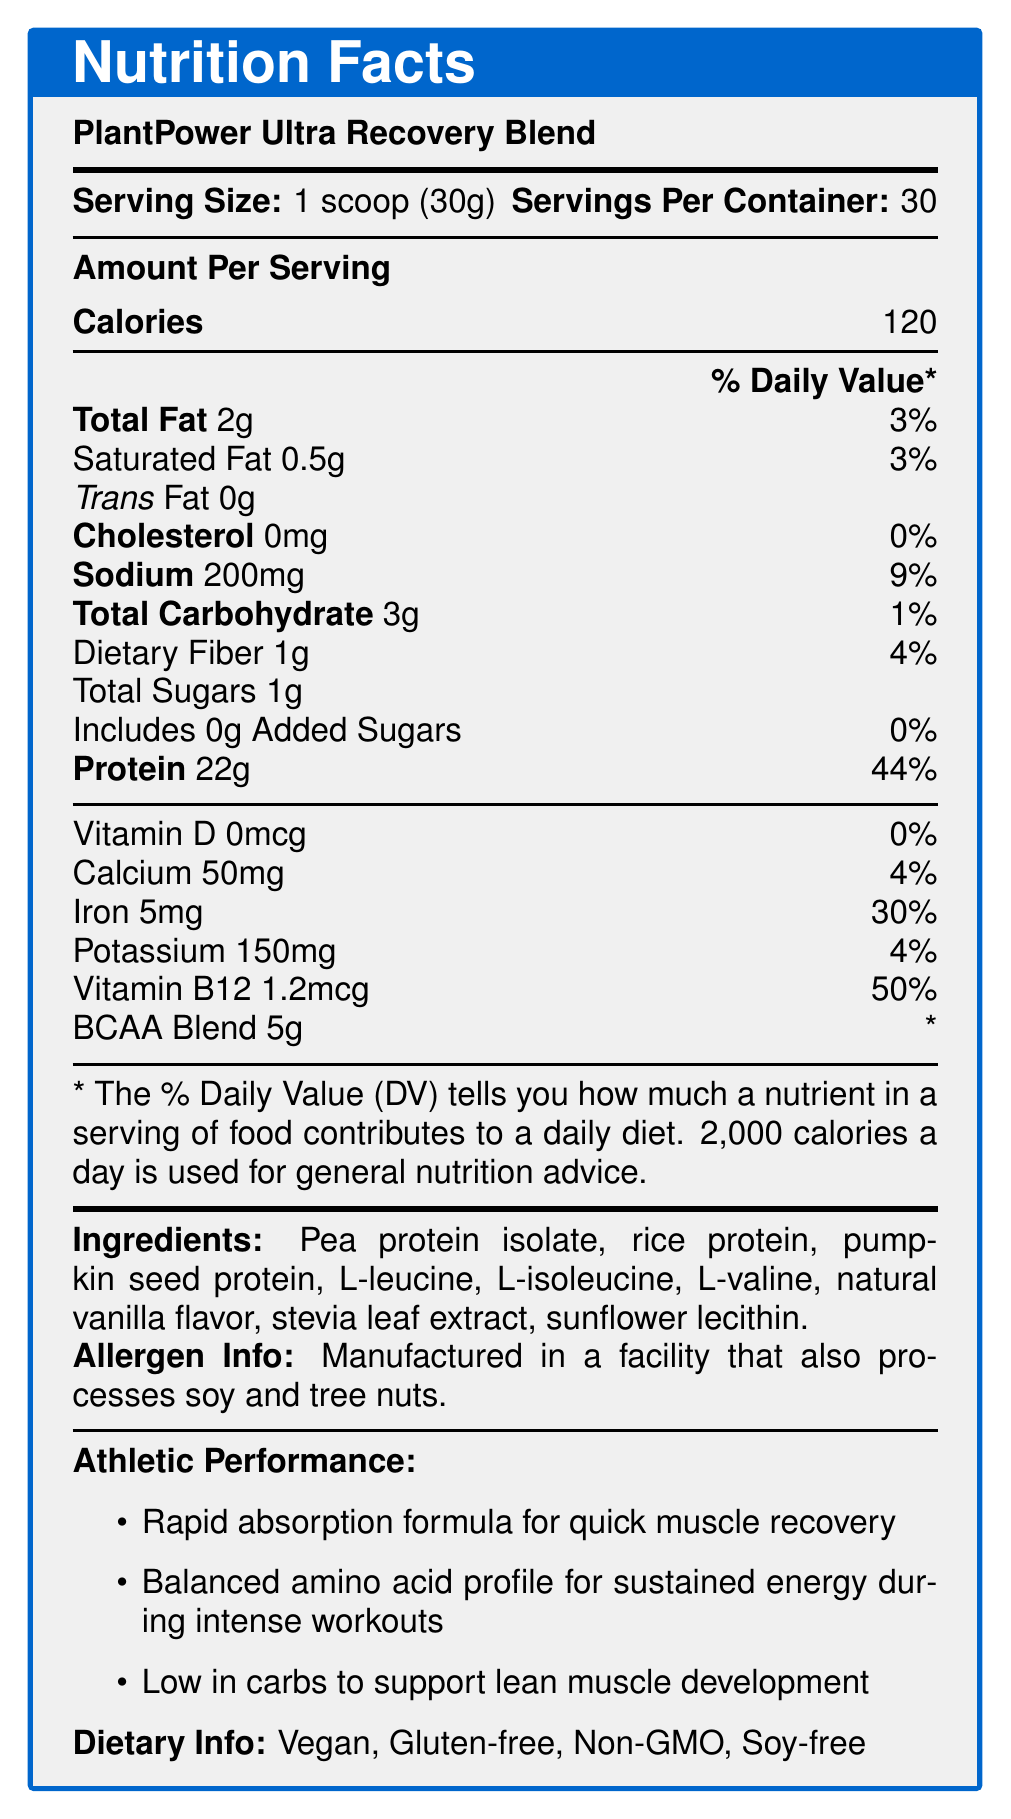Which product is described in the document? The product name is mentioned at the very start of the document.
Answer: PlantPower Ultra Recovery Blend What is the serving size for this protein powder? The serving size is clearly listed next to the product name and serving information.
Answer: 1 scoop (30g) How many calories does one serving contain? The document states that each serving contains 120 calories.
Answer: 120 What is the total fat content per serving? Total fat per serving is listed as 2g.
Answer: 2g What percentage of the daily value of iron does one serving provide? The document mentions the iron content and its daily value percentage.
Answer: 30% Does this product contain any added sugars? The Nutrition Facts label shows 0g of added sugars.
Answer: No Is it suitable for someone who avoids soy? The dietary info section lists it as soy-free.
Answer: Yes What is the sodium content per serving? According to the Nutrition Facts, each serving contains 200mg of sodium.
Answer: 200mg Does this product contain cholesterol? The label shows 0mg of cholesterol per serving.
Answer: No How much protein does one serving contain? The document states that each serving contains 22g of protein.
Answer: 22g What is a unique feature of this protein powder? A. Contains caffeine B. Added BCAAs C. Low in sodium The product is specifically highlighted for having added BCAAs for muscle recovery.
Answer: B Which vitamin has the highest daily value percentage? A. Vitamin D B. Calcium C. Vitamin B12 D. Iron Vitamin B12 has a daily value of 50%, which is the highest among the listed vitamins and minerals.
Answer: C Is the product gluten-free? It is mentioned as one of the dietary info claims.
Answer: Yes Summarize the main benefits of PlantPower Ultra Recovery Blend. This summary encompasses the primary claims about athletic performance and benefits highlighted in the document.
Answer: It supports muscle recovery and growth, is enhanced with BCAAs for optimal performance, and is ideal for pre and post-workout nutrition. What are the main ingredients of this protein powder? These ingredients are listed in the document.
Answer: Pea protein isolate, rice protein, pumpkin seed protein, L-leucine, L-isoleucine, L-valine, natural vanilla flavor, stevia leaf extract, sunflower lecithin. How many servings does one container have? The document specifies that there are 30 servings per container.
Answer: 30 Does the product have any trans fat? The label lists 0g of trans fat per serving.
Answer: No Is the daily value percentage for potassium more than that of calcium? Potassium's daily value is 4%, which is the same as calcium's daily value.
Answer: Yes Can it be determined where this product is manufactured? The document does not provide any details about the manufacturing location.
Answer: Not enough information 